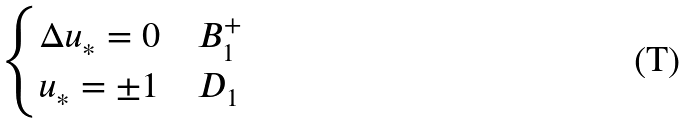<formula> <loc_0><loc_0><loc_500><loc_500>\begin{cases} \Delta u _ { * } = 0 & B _ { 1 } ^ { + } \\ u _ { * } = \pm 1 & D _ { 1 } \end{cases}</formula> 